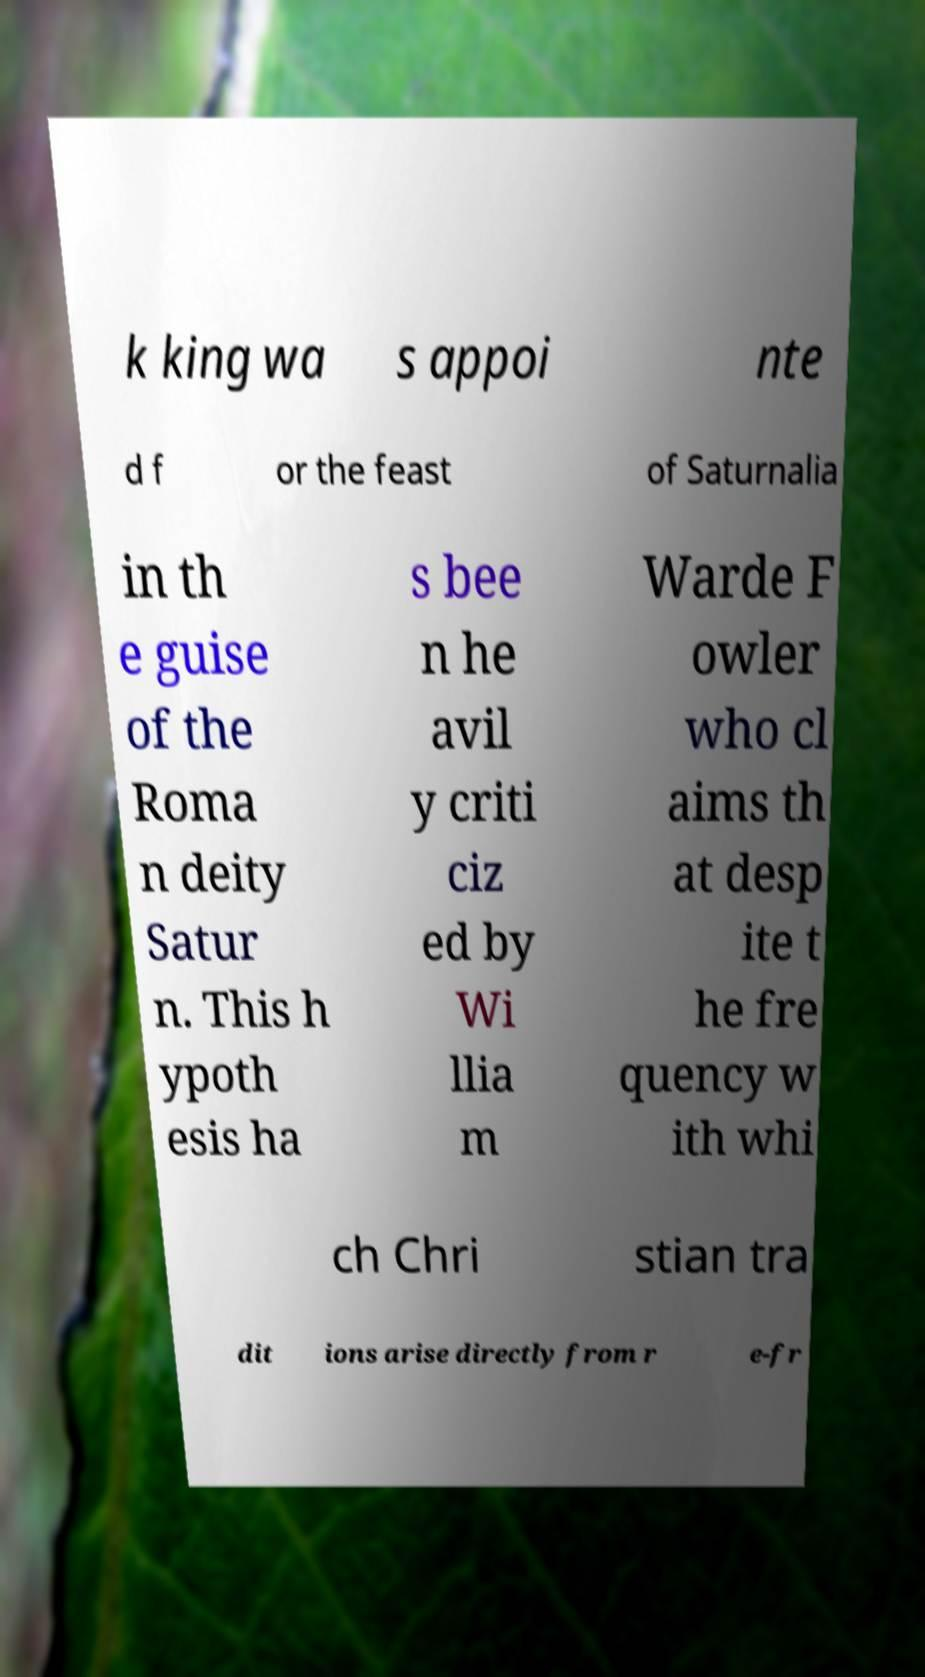Could you assist in decoding the text presented in this image and type it out clearly? k king wa s appoi nte d f or the feast of Saturnalia in th e guise of the Roma n deity Satur n. This h ypoth esis ha s bee n he avil y criti ciz ed by Wi llia m Warde F owler who cl aims th at desp ite t he fre quency w ith whi ch Chri stian tra dit ions arise directly from r e-fr 